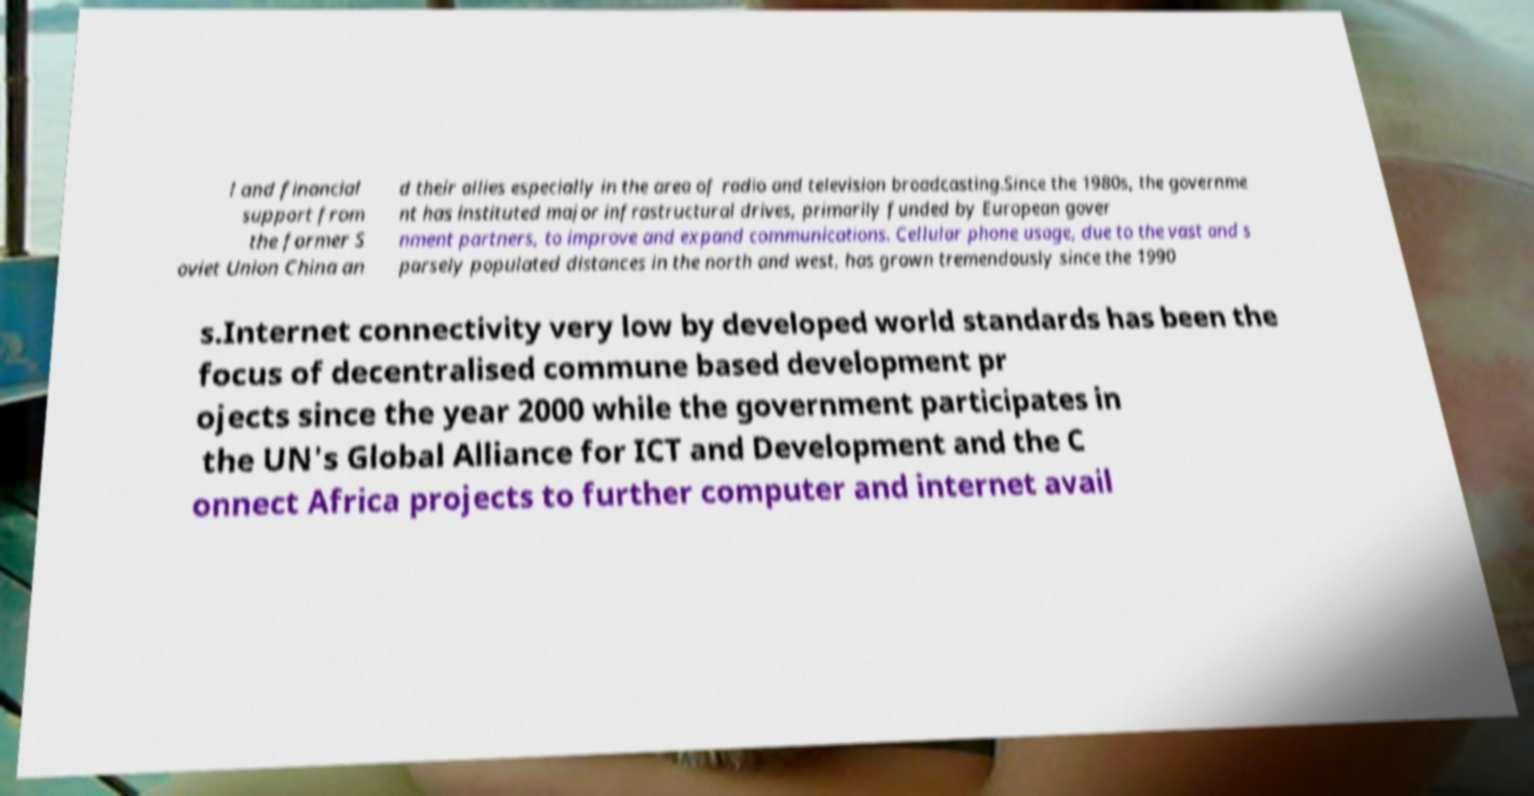There's text embedded in this image that I need extracted. Can you transcribe it verbatim? l and financial support from the former S oviet Union China an d their allies especially in the area of radio and television broadcasting.Since the 1980s, the governme nt has instituted major infrastructural drives, primarily funded by European gover nment partners, to improve and expand communications. Cellular phone usage, due to the vast and s parsely populated distances in the north and west, has grown tremendously since the 1990 s.Internet connectivity very low by developed world standards has been the focus of decentralised commune based development pr ojects since the year 2000 while the government participates in the UN's Global Alliance for ICT and Development and the C onnect Africa projects to further computer and internet avail 